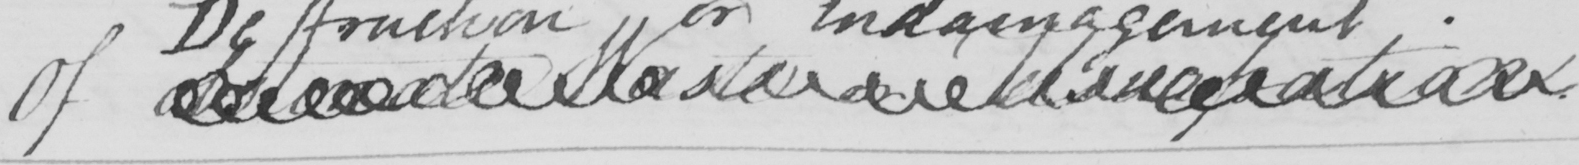Please provide the text content of this handwritten line. Of obstinate waster or usurpation . 